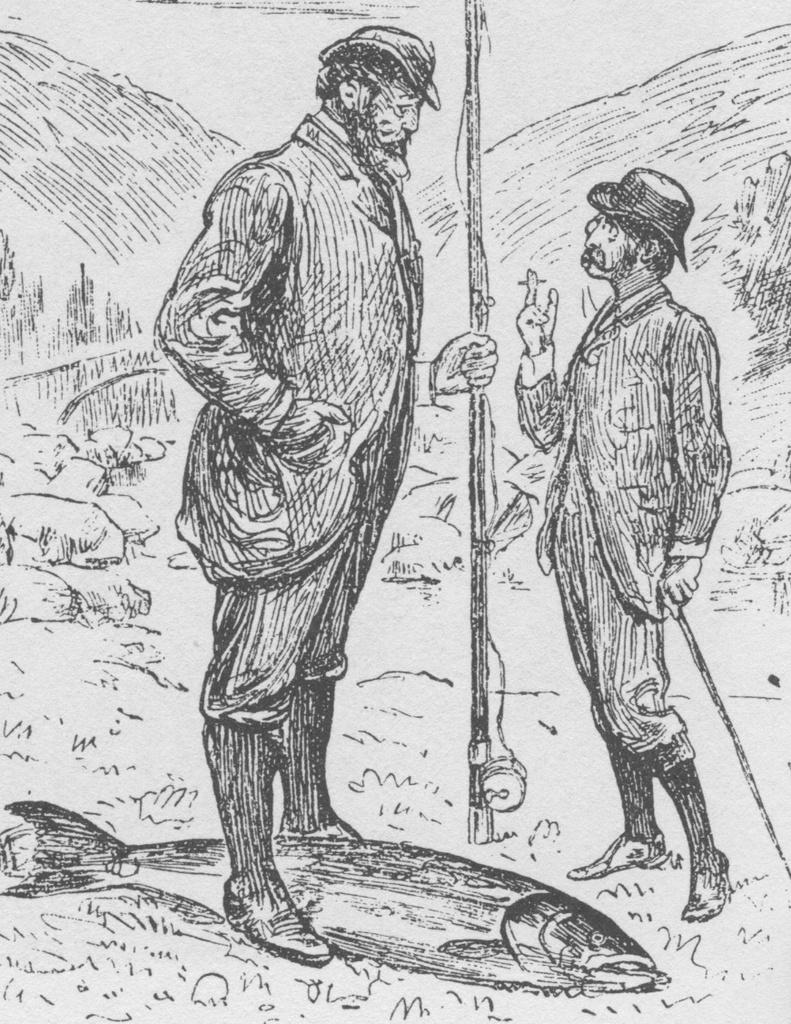How many people are depicted in the drawing? There are two persons in the drawing. What are the persons holding in their hands? The persons are holding sticks in their hands. What other element is present in the drawing? There is a fish in the drawing. What question is being asked by the person on the left in the drawing? There is no indication of a question being asked in the drawing, as it only shows two persons holding sticks and a fish. 